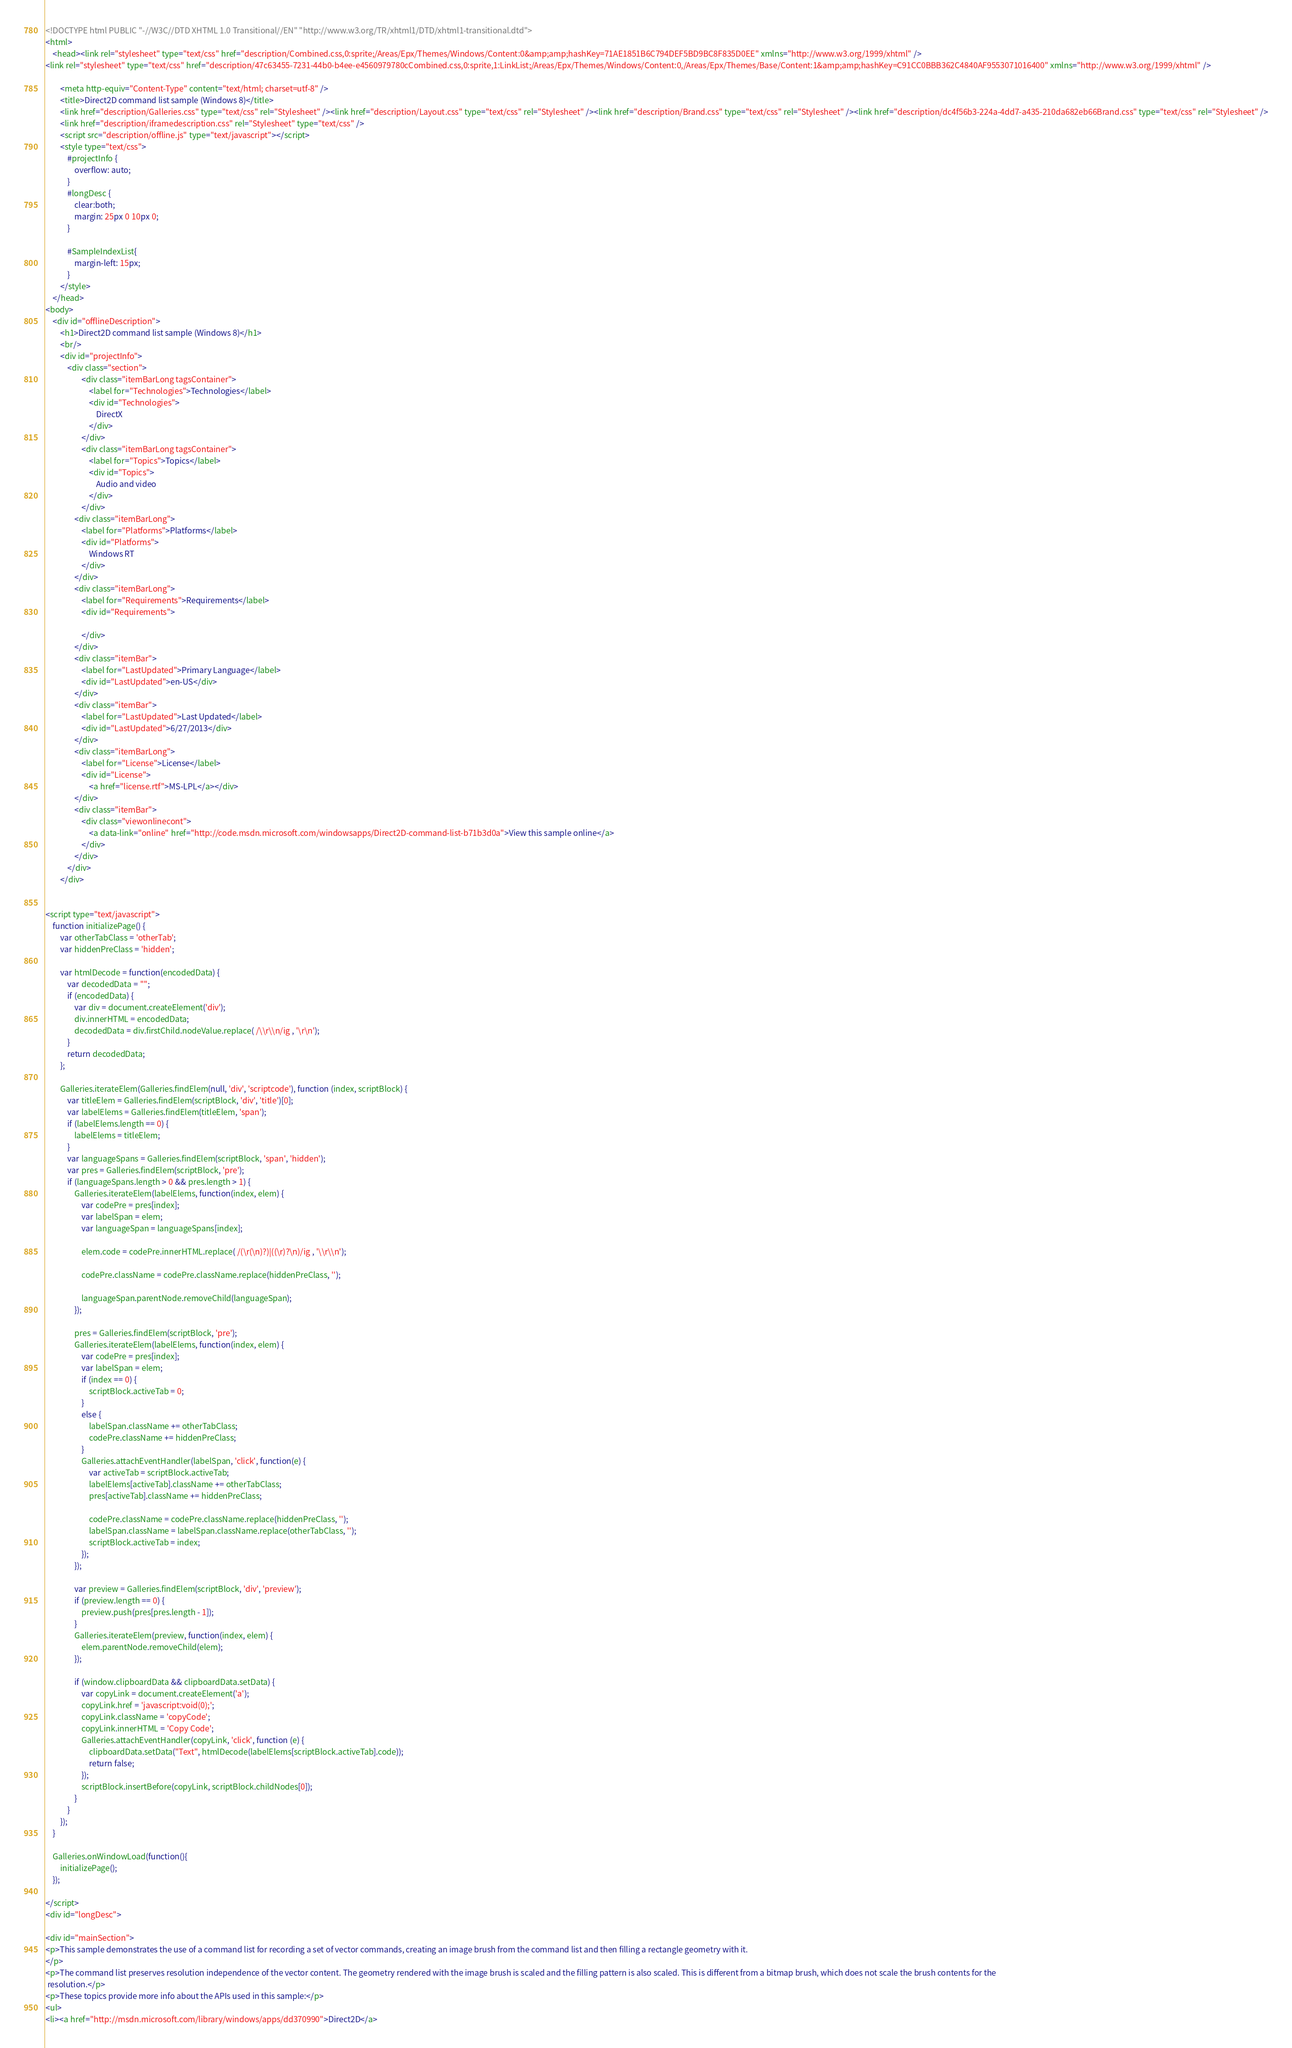<code> <loc_0><loc_0><loc_500><loc_500><_HTML_><!DOCTYPE html PUBLIC "-//W3C//DTD XHTML 1.0 Transitional//EN" "http://www.w3.org/TR/xhtml1/DTD/xhtml1-transitional.dtd">
<html>
    <head><link rel="stylesheet" type="text/css" href="description/Combined.css,0:sprite;/Areas/Epx/Themes/Windows/Content:0&amp;amp;hashKey=71AE1851B6C794DEF5BD9BC8F835D0EE" xmlns="http://www.w3.org/1999/xhtml" />
<link rel="stylesheet" type="text/css" href="description/47c63455-7231-44b0-b4ee-e4560979780cCombined.css,0:sprite,1:LinkList;/Areas/Epx/Themes/Windows/Content:0,/Areas/Epx/Themes/Base/Content:1&amp;amp;hashKey=C91CC0BBB362C4840AF9553071016400" xmlns="http://www.w3.org/1999/xhtml" />

        <meta http-equiv="Content-Type" content="text/html; charset=utf-8" />
        <title>Direct2D command list sample (Windows 8)</title>
        <link href="description/Galleries.css" type="text/css" rel="Stylesheet" /><link href="description/Layout.css" type="text/css" rel="Stylesheet" /><link href="description/Brand.css" type="text/css" rel="Stylesheet" /><link href="description/dc4f56b3-224a-4dd7-a435-210da682eb66Brand.css" type="text/css" rel="Stylesheet" />
        <link href="description/iframedescription.css" rel="Stylesheet" type="text/css" />
        <script src="description/offline.js" type="text/javascript"></script>
        <style type="text/css">
            #projectInfo {
                overflow: auto;
            }
            #longDesc {
                clear:both;
                margin: 25px 0 10px 0;
            }

            #SampleIndexList{
                margin-left: 15px;
            }
        </style>
    </head>
<body>
    <div id="offlineDescription">
        <h1>Direct2D command list sample (Windows 8)</h1>
        <br/>
        <div id="projectInfo">
            <div class="section">
                    <div class="itemBarLong tagsContainer">
                        <label for="Technologies">Technologies</label>
                        <div id="Technologies">
                            DirectX
                        </div>
                    </div>
                    <div class="itemBarLong tagsContainer">
                        <label for="Topics">Topics</label>
                        <div id="Topics">
                            Audio and video
                        </div>
                    </div>
                <div class="itemBarLong">
                    <label for="Platforms">Platforms</label>
                    <div id="Platforms">
                        Windows RT
                    </div>
                </div>
                <div class="itemBarLong">
                    <label for="Requirements">Requirements</label>
                    <div id="Requirements">
                        
                    </div>
                </div>
                <div class="itemBar">
                    <label for="LastUpdated">Primary Language</label>
                    <div id="LastUpdated">en-US</div>
                </div>
                <div class="itemBar">
                    <label for="LastUpdated">Last Updated</label>
                    <div id="LastUpdated">6/27/2013</div>
                </div>
                <div class="itemBarLong">
                    <label for="License">License</label>
                    <div id="License">
                        <a href="license.rtf">MS-LPL</a></div>
                </div>
                <div class="itemBar">
                    <div class="viewonlinecont">
                        <a data-link="online" href="http://code.msdn.microsoft.com/windowsapps/Direct2D-command-list-b71b3d0a">View this sample online</a>
                    </div>
                </div>
            </div>
        </div>
        
                   
<script type="text/javascript">
    function initializePage() {
        var otherTabClass = 'otherTab';
        var hiddenPreClass = 'hidden';

        var htmlDecode = function(encodedData) {
            var decodedData = "";
            if (encodedData) {
                var div = document.createElement('div');
                div.innerHTML = encodedData;
                decodedData = div.firstChild.nodeValue.replace( /\\r\\n/ig , '\r\n');
            }
            return decodedData;
        };
                
        Galleries.iterateElem(Galleries.findElem(null, 'div', 'scriptcode'), function (index, scriptBlock) {
            var titleElem = Galleries.findElem(scriptBlock, 'div', 'title')[0];
            var labelElems = Galleries.findElem(titleElem, 'span');
            if (labelElems.length == 0) {
                labelElems = titleElem;
            }
            var languageSpans = Galleries.findElem(scriptBlock, 'span', 'hidden');
            var pres = Galleries.findElem(scriptBlock, 'pre');
            if (languageSpans.length > 0 && pres.length > 1) {
                Galleries.iterateElem(labelElems, function(index, elem) {
                    var codePre = pres[index];
                    var labelSpan = elem;
                    var languageSpan = languageSpans[index];
                            
                    elem.code = codePre.innerHTML.replace( /(\r(\n)?)|((\r)?\n)/ig , '\\r\\n');
                            
                    codePre.className = codePre.className.replace(hiddenPreClass, '');
                            
                    languageSpan.parentNode.removeChild(languageSpan);
                });

                pres = Galleries.findElem(scriptBlock, 'pre');
                Galleries.iterateElem(labelElems, function(index, elem) {
                    var codePre = pres[index];
                    var labelSpan = elem;
                    if (index == 0) {
                        scriptBlock.activeTab = 0;
                    }
                    else {
                        labelSpan.className += otherTabClass;
                        codePre.className += hiddenPreClass;
                    }
                    Galleries.attachEventHandler(labelSpan, 'click', function(e) {
                        var activeTab = scriptBlock.activeTab;
                        labelElems[activeTab].className += otherTabClass;
                        pres[activeTab].className += hiddenPreClass;

                        codePre.className = codePre.className.replace(hiddenPreClass, '');
                        labelSpan.className = labelSpan.className.replace(otherTabClass, '');
                        scriptBlock.activeTab = index;
                    });
                });

                var preview = Galleries.findElem(scriptBlock, 'div', 'preview');
                if (preview.length == 0) {
                    preview.push(pres[pres.length - 1]);
                }
                Galleries.iterateElem(preview, function(index, elem) {
                    elem.parentNode.removeChild(elem);
                });

                if (window.clipboardData && clipboardData.setData) {
                    var copyLink = document.createElement('a');
                    copyLink.href = 'javascript:void(0);';
                    copyLink.className = 'copyCode';
                    copyLink.innerHTML = 'Copy Code';
                    Galleries.attachEventHandler(copyLink, 'click', function (e) {
                        clipboardData.setData("Text", htmlDecode(labelElems[scriptBlock.activeTab].code));
                        return false;
                    });
                    scriptBlock.insertBefore(copyLink, scriptBlock.childNodes[0]);
                }
            }
        });
    }

    Galleries.onWindowLoad(function(){
        initializePage();
    });

</script>
<div id="longDesc">
    
<div id="mainSection">
<p>This sample demonstrates the use of a command list for recording a set of vector commands, creating an image brush from the command list and then filling a rectangle geometry with it.
</p>
<p>The command list preserves resolution independence of the vector content. The geometry rendered with the image brush is scaled and the filling pattern is also scaled. This is different from a bitmap brush, which does not scale the brush contents for the
 resolution.</p>
<p>These topics provide more info about the APIs used in this sample:</p>
<ul>
<li><a href="http://msdn.microsoft.com/library/windows/apps/dd370990">Direct2D</a></code> 